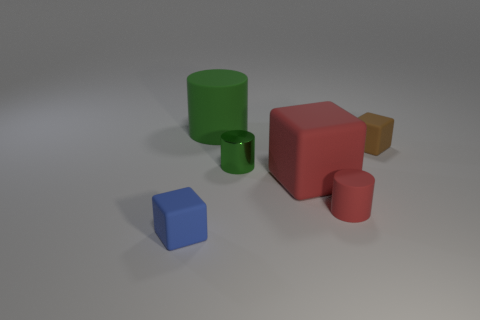Add 2 small blocks. How many objects exist? 8 Subtract all tiny rubber cubes. Subtract all big red matte objects. How many objects are left? 3 Add 5 tiny objects. How many tiny objects are left? 9 Add 5 small metal objects. How many small metal objects exist? 6 Subtract 0 gray cubes. How many objects are left? 6 